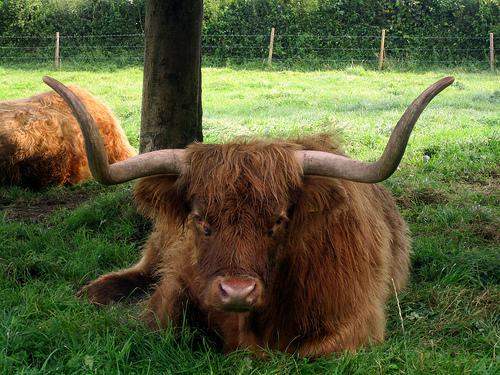Question: where is this picture taken?
Choices:
A. Beach.
B. Farm.
C. Parking lot.
D. Zoo.
Answer with the letter. Answer: B Question: why is this picture taken?
Choices:
A. For memories.
B. For fun.
C. Photography.
D. On a dare.
Answer with the letter. Answer: C Question: what color is the bulls hors?
Choices:
A. Gray.
B. White.
C. Yellow.
D. Black.
Answer with the letter. Answer: A Question: what is pictured?
Choices:
A. Buffalo.
B. Horse.
C. Bull.
D. Sheep.
Answer with the letter. Answer: C Question: when is this picture taken?
Choices:
A. When cow was eating.
B. While bull is sleeping.
C. When sheep were grazing.
D. When dogs were playing.
Answer with the letter. Answer: B 